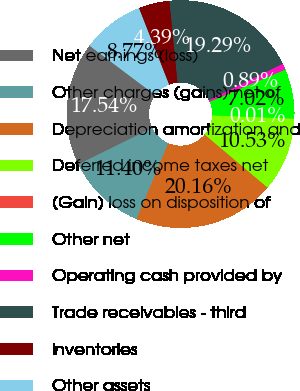<chart> <loc_0><loc_0><loc_500><loc_500><pie_chart><fcel>Net earnings (loss)<fcel>Other charges (gains) net of<fcel>Depreciation amortization and<fcel>Deferred income taxes net<fcel>(Gain) loss on disposition of<fcel>Other net<fcel>Operating cash provided by<fcel>Trade receivables - third<fcel>Inventories<fcel>Other assets<nl><fcel>17.54%<fcel>11.4%<fcel>20.16%<fcel>10.53%<fcel>0.01%<fcel>7.02%<fcel>0.89%<fcel>19.29%<fcel>4.39%<fcel>8.77%<nl></chart> 